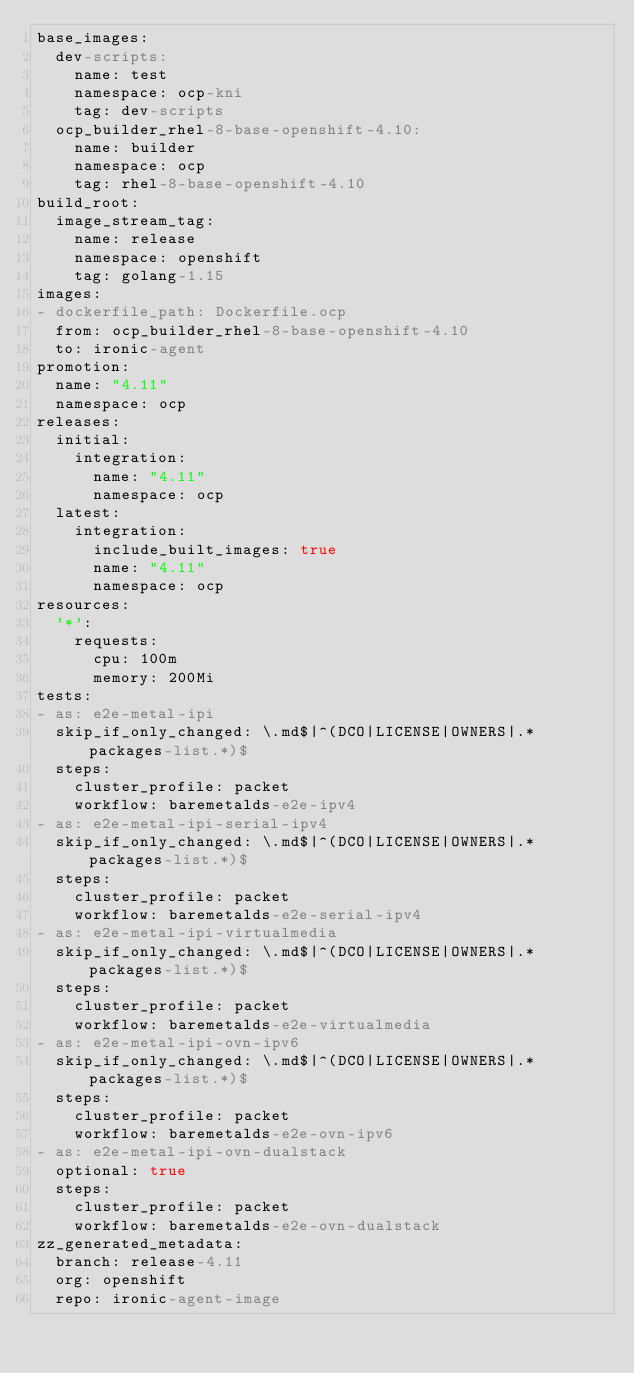<code> <loc_0><loc_0><loc_500><loc_500><_YAML_>base_images:
  dev-scripts:
    name: test
    namespace: ocp-kni
    tag: dev-scripts
  ocp_builder_rhel-8-base-openshift-4.10:
    name: builder
    namespace: ocp
    tag: rhel-8-base-openshift-4.10
build_root:
  image_stream_tag:
    name: release
    namespace: openshift
    tag: golang-1.15
images:
- dockerfile_path: Dockerfile.ocp
  from: ocp_builder_rhel-8-base-openshift-4.10
  to: ironic-agent
promotion:
  name: "4.11"
  namespace: ocp
releases:
  initial:
    integration:
      name: "4.11"
      namespace: ocp
  latest:
    integration:
      include_built_images: true
      name: "4.11"
      namespace: ocp
resources:
  '*':
    requests:
      cpu: 100m
      memory: 200Mi
tests:
- as: e2e-metal-ipi
  skip_if_only_changed: \.md$|^(DCO|LICENSE|OWNERS|.*packages-list.*)$
  steps:
    cluster_profile: packet
    workflow: baremetalds-e2e-ipv4
- as: e2e-metal-ipi-serial-ipv4
  skip_if_only_changed: \.md$|^(DCO|LICENSE|OWNERS|.*packages-list.*)$
  steps:
    cluster_profile: packet
    workflow: baremetalds-e2e-serial-ipv4
- as: e2e-metal-ipi-virtualmedia
  skip_if_only_changed: \.md$|^(DCO|LICENSE|OWNERS|.*packages-list.*)$
  steps:
    cluster_profile: packet
    workflow: baremetalds-e2e-virtualmedia
- as: e2e-metal-ipi-ovn-ipv6
  skip_if_only_changed: \.md$|^(DCO|LICENSE|OWNERS|.*packages-list.*)$
  steps:
    cluster_profile: packet
    workflow: baremetalds-e2e-ovn-ipv6
- as: e2e-metal-ipi-ovn-dualstack
  optional: true
  steps:
    cluster_profile: packet
    workflow: baremetalds-e2e-ovn-dualstack
zz_generated_metadata:
  branch: release-4.11
  org: openshift
  repo: ironic-agent-image
</code> 